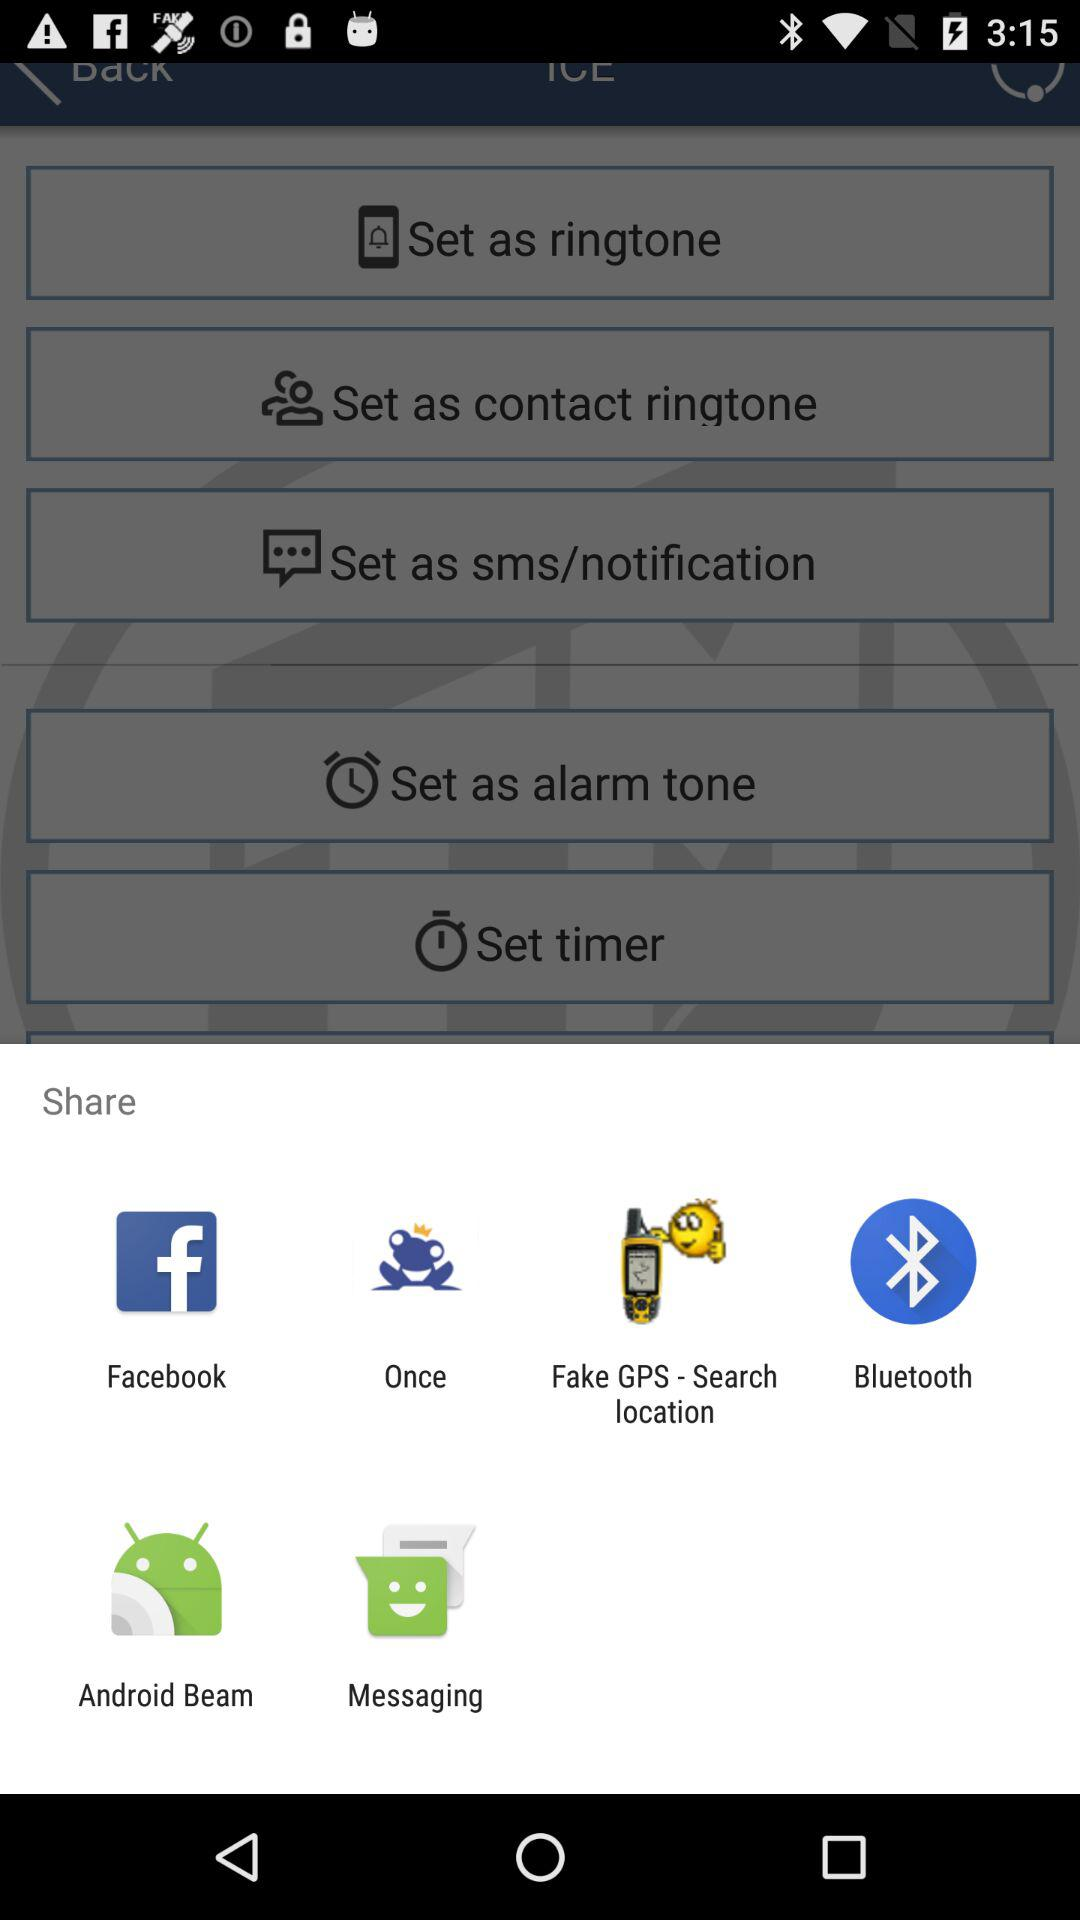What are the different mediums to share? The different mediums to share are "Facebook", "Once", "Fake GPS - Search location", "Bluetooth", "Android Beam" and "Messaging". 